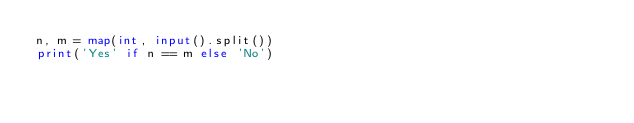Convert code to text. <code><loc_0><loc_0><loc_500><loc_500><_Python_>n, m = map(int, input().split())
print('Yes' if n == m else 'No')</code> 